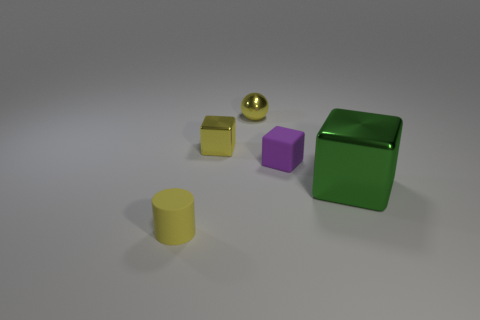Does the small metallic block have the same color as the tiny metallic sphere?
Provide a short and direct response. Yes. There is a cylinder that is the same color as the tiny ball; what is its material?
Provide a succinct answer. Rubber. Is the number of small things behind the tiny yellow metal cube less than the number of small red spheres?
Provide a short and direct response. No. There is a tiny matte object that is on the right side of the yellow cube; is there a big thing that is to the right of it?
Offer a terse response. Yes. Is there anything else that is the same shape as the tiny yellow matte thing?
Your answer should be compact. No. Do the yellow metallic block and the sphere have the same size?
Ensure brevity in your answer.  Yes. There is a yellow object that is in front of the small matte thing that is behind the small rubber object that is to the left of the sphere; what is its material?
Ensure brevity in your answer.  Rubber. Is the number of large cubes to the left of the small yellow metal ball the same as the number of small blue shiny spheres?
Offer a very short reply. Yes. Are there any other things that are the same size as the green shiny block?
Keep it short and to the point. No. What number of objects are either green metallic objects or blue matte cubes?
Keep it short and to the point. 1. 